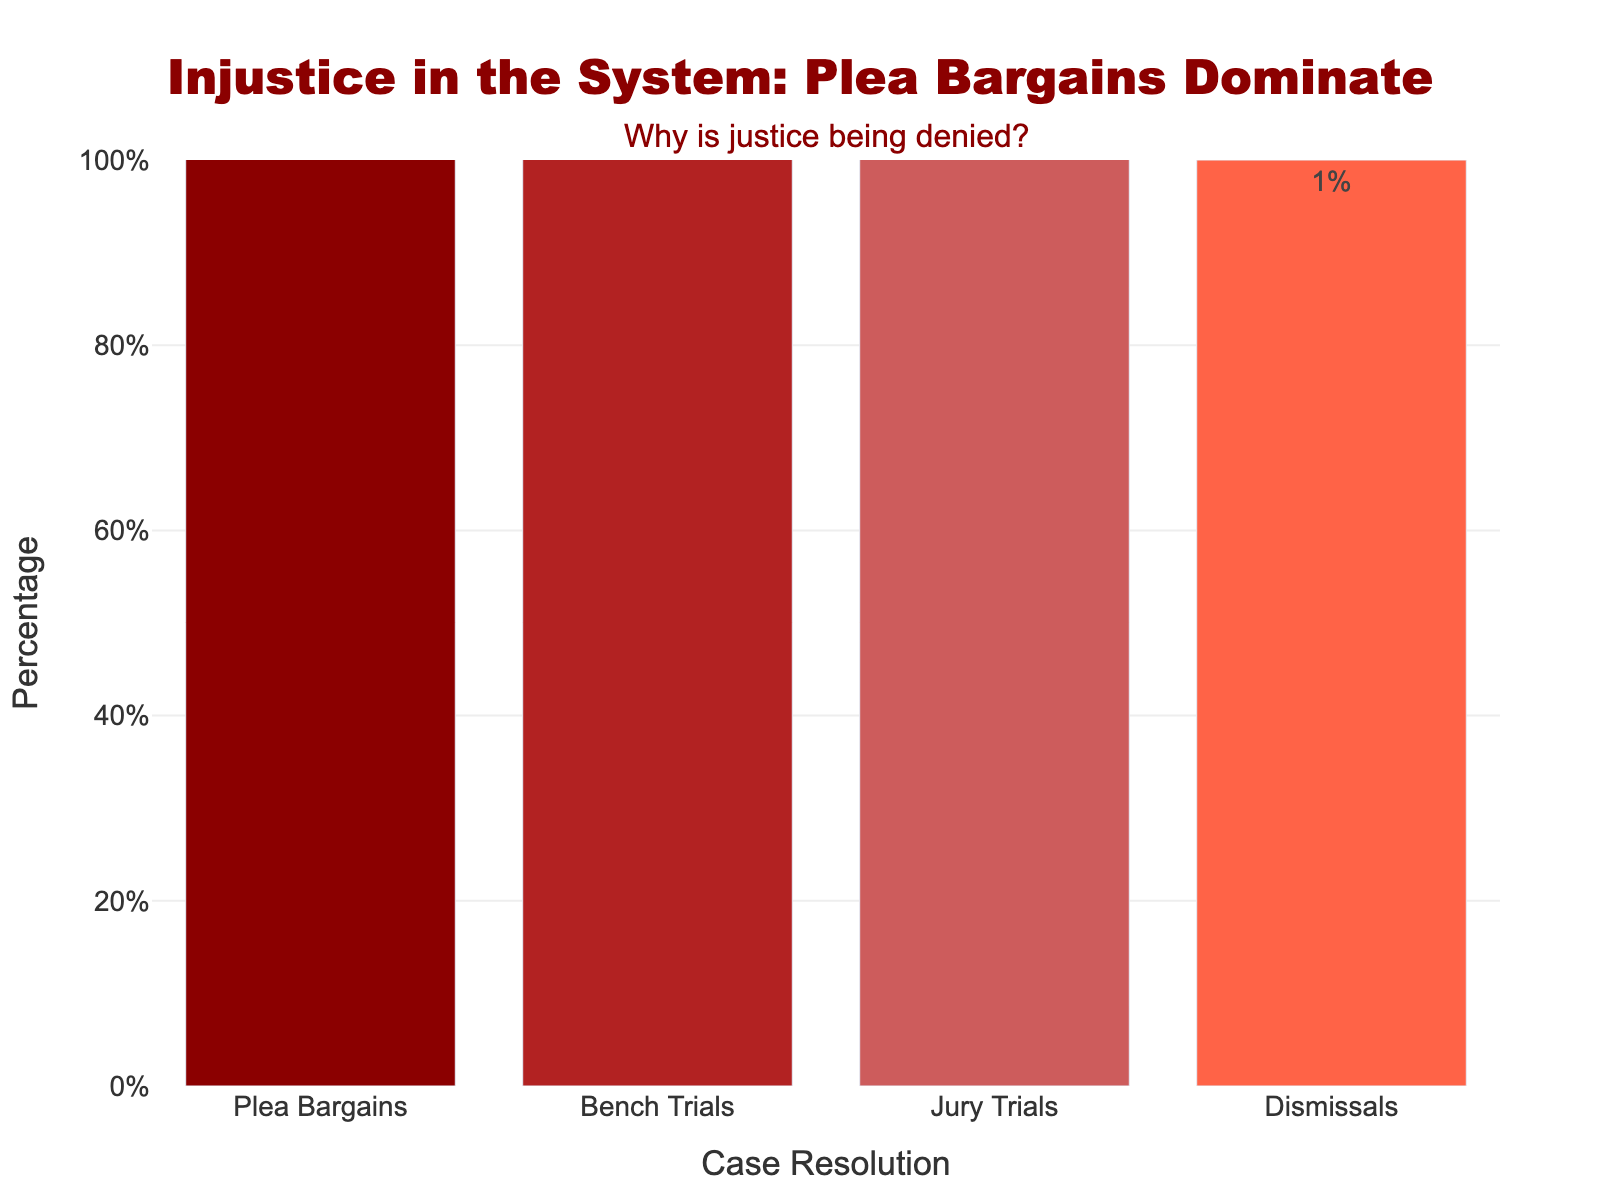What's the most common resolution method for criminal cases? The tallest bar in the chart represents the most common resolution method. The bar for Plea Bargains is the tallest, indicating it is the most frequent resolution method.
Answer: Plea Bargains What percentage of cases are resolved through trials? To find the total percentage of cases resolved through trials, add the percentage of Bench Trials and Jury Trials. Bench Trials are 2% and Jury Trials are 3%, so the sum is 2% + 3%.
Answer: 5% How does the percentage of dismissals compare to bench trials? The bar for Dismissals is at 1%, and the bar for Bench Trials is at 2%. The bar for Dismissals is shorter, indicating a lower percentage.
Answer: Dismissals is lower What is the combined percentage of Plea Bargains and Jury Trials? Add the percentage of Plea Bargains and Jury Trials. Plea Bargains are 94% and Jury Trials are 3%, so 94% + 3%.
Answer: 97% Which resolution method has the smallest percentage? The shortest bar in the chart represents the smallest percentage. The Dismissals bar is the shortest, indicating it has the smallest percentage.
Answer: Dismissals If 1000 cases are considered, approximately how many are resolved through Plea Bargains? Multiply the total number of cases by the percentage of Plea Bargains. 1000 * 94% = 1000 * 0.94.
Answer: 940 cases How much more common are Jury Trials than Dismissals, percentage-wise? Subtract the percentage of Dismissals from the percentage of Jury Trials. 3% (Jury Trials) - 1% (Dismissals).
Answer: 2% What does the annotation in the chart ask about? The chart has an annotation at the top asking, "Why is justice being denied?" This is a qualitative question about the high percentage of Plea Bargains.
Answer: Why is justice being denied? Which bar is colored the darkest shade of red? Among the different shades of red used on the bars, the darkest shade corresponds to Plea Bargains, as indicated by the legend.
Answer: Plea Bargains 